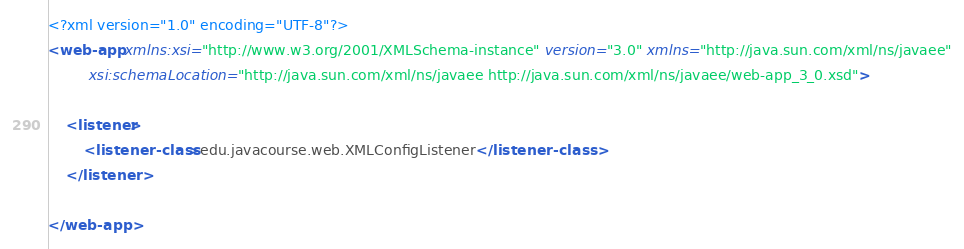<code> <loc_0><loc_0><loc_500><loc_500><_XML_><?xml version="1.0" encoding="UTF-8"?>
<web-app xmlns:xsi="http://www.w3.org/2001/XMLSchema-instance" version="3.0" xmlns="http://java.sun.com/xml/ns/javaee"
         xsi:schemaLocation="http://java.sun.com/xml/ns/javaee http://java.sun.com/xml/ns/javaee/web-app_3_0.xsd">

    <listener>
        <listener-class>edu.javacourse.web.XMLConfigListener</listener-class>
    </listener>

</web-app>
</code> 